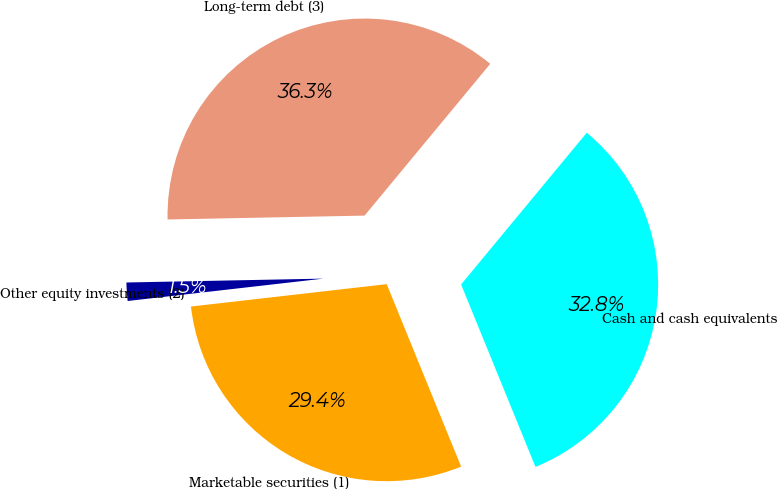Convert chart to OTSL. <chart><loc_0><loc_0><loc_500><loc_500><pie_chart><fcel>Cash and cash equivalents<fcel>Marketable securities (1)<fcel>Other equity investments (2)<fcel>Long-term debt (3)<nl><fcel>32.83%<fcel>29.35%<fcel>1.5%<fcel>36.32%<nl></chart> 